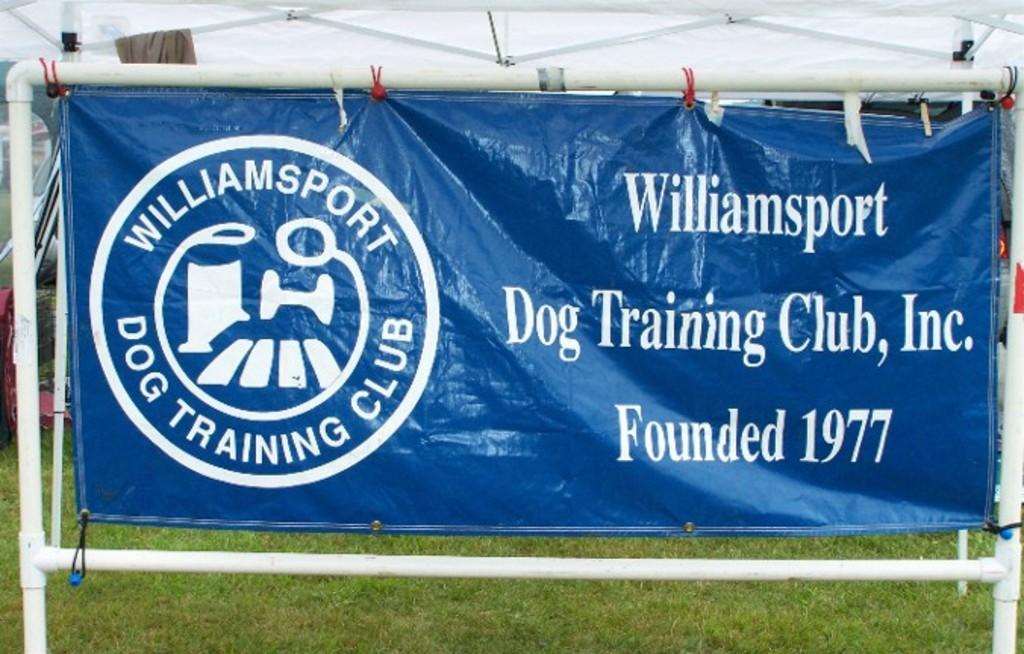What is hanging from a pole in the image? There is a banner hanging from a pole in the image. Where is the banner located in relation to the tent? The banner is under a tent in the image. What type of brush is being used to clean the trucks in the image? There are no trucks or brushes present in the image; it only features a banner hanging from a pole and located under a tent. 